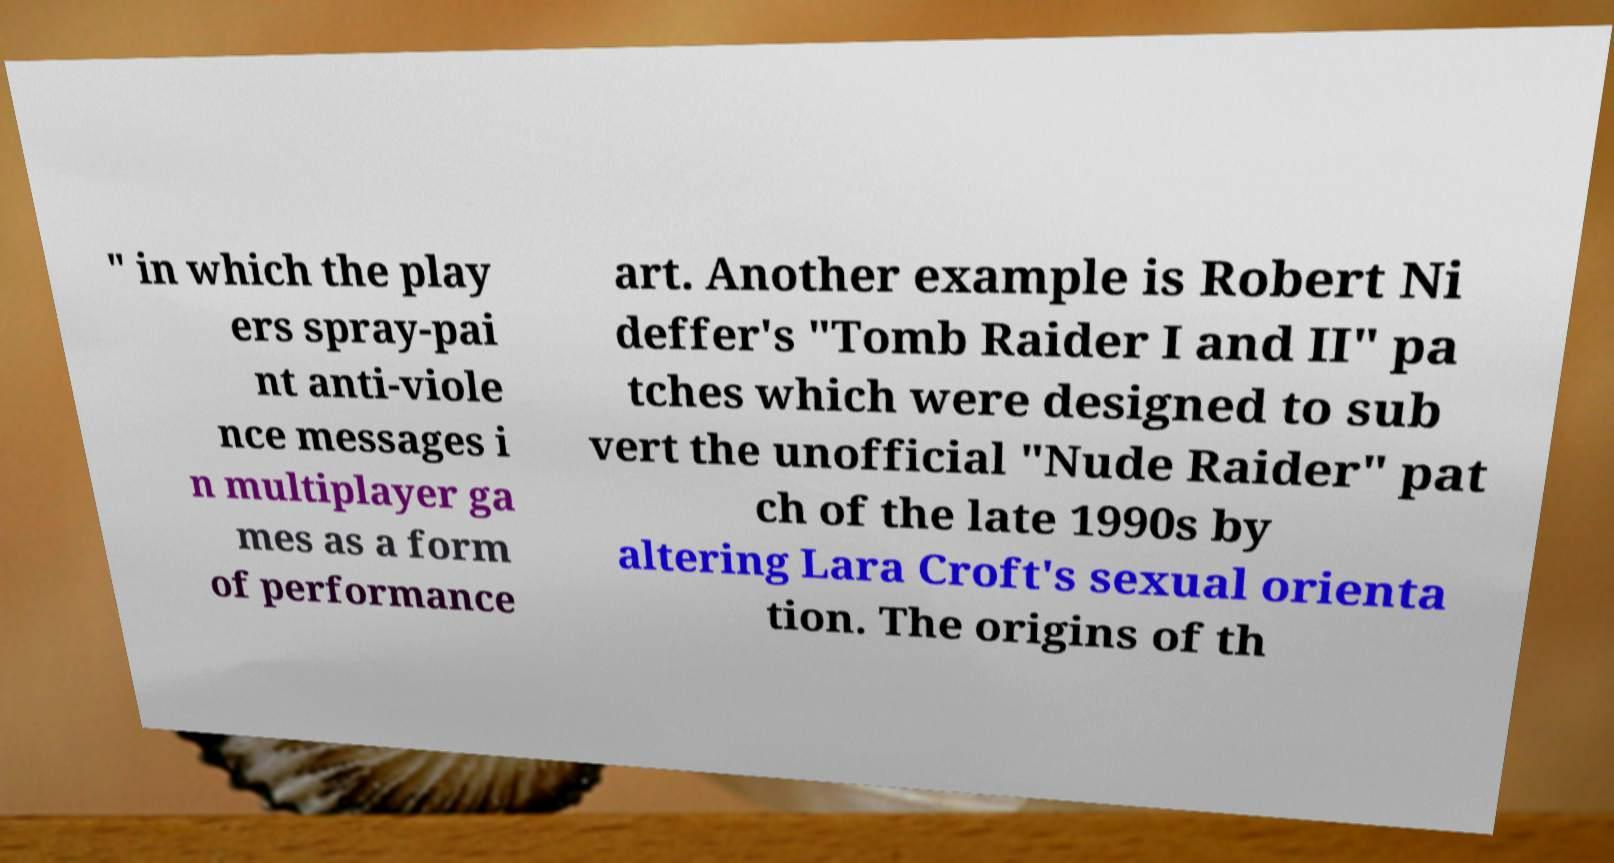For documentation purposes, I need the text within this image transcribed. Could you provide that? " in which the play ers spray-pai nt anti-viole nce messages i n multiplayer ga mes as a form of performance art. Another example is Robert Ni deffer's "Tomb Raider I and II" pa tches which were designed to sub vert the unofficial "Nude Raider" pat ch of the late 1990s by altering Lara Croft's sexual orienta tion. The origins of th 